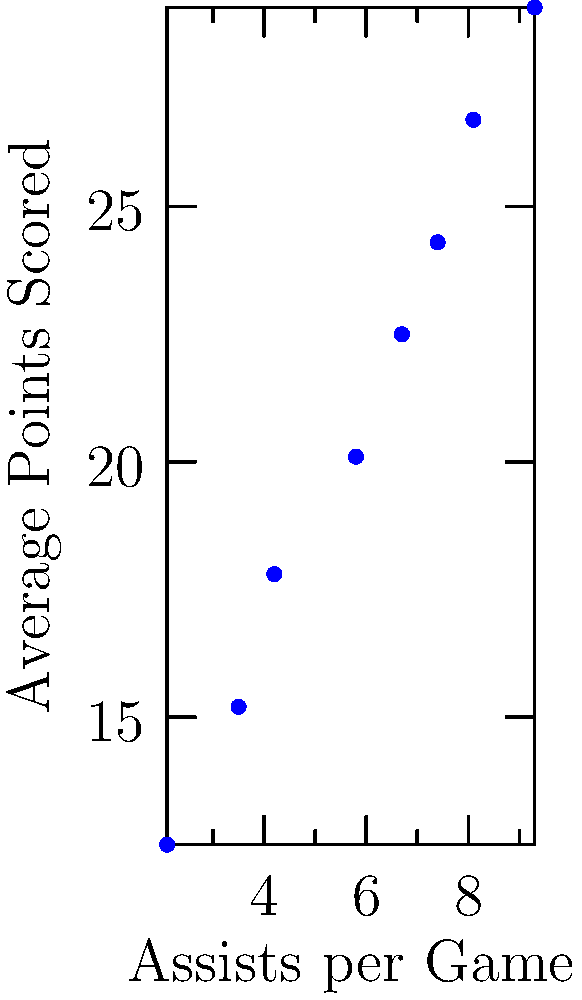Examining the scatter plot of average points scored versus assists per game for the UConn women's basketball team, what narrative does this data tell about the relationship between a player's scoring and their ability to set up teammates? To interpret this scatter plot and understand the relationship between scoring and assists, let's break it down step-by-step:

1. Observe the overall pattern: The dots on the graph show a clear upward trend from left to right.

2. Interpret the axes: The horizontal axis represents assists per game, while the vertical axis shows average points scored.

3. Understand the correlation: The upward trend suggests a positive correlation between assists and points scored. As assists increase, points tend to increase as well.

4. Notice the red trend line: This line represents the general trend of the data, reinforcing the positive relationship between the two variables.

5. Consider individual data points: While there's a general trend, some points deviate from the line, indicating that the relationship isn't perfect.

6. Reflect on basketball strategy: This relationship suggests that players who are good at assisting are often good scorers too. It could indicate that:
   a) Skilled players excel in both areas
   b) Players who assist well create opportunities for themselves to score
   c) The team's offensive strategy encourages both assisting and scoring from key players

7. Think about the team's playing style: This data might reflect UConn's emphasis on well-rounded players who contribute in multiple ways on offense.

8. Consider player development: The trend could suggest that as players improve their ability to assist, their scoring also tends to improve, or vice versa.

This analysis tells a story of versatile players and a team strategy that values both scoring and playmaking, typical of UConn's successful approach to women's basketball.
Answer: The scatter plot reveals a positive correlation between assists and scoring, suggesting UConn's players are versatile, excelling in both playmaking and scoring roles. 